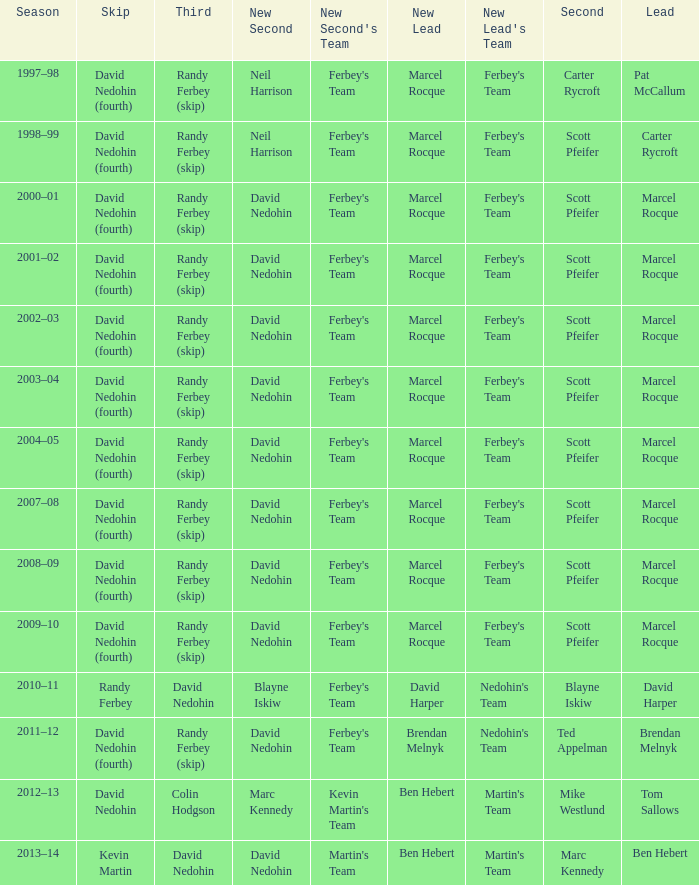Which Skip has a Season of 2002–03? David Nedohin (fourth). 